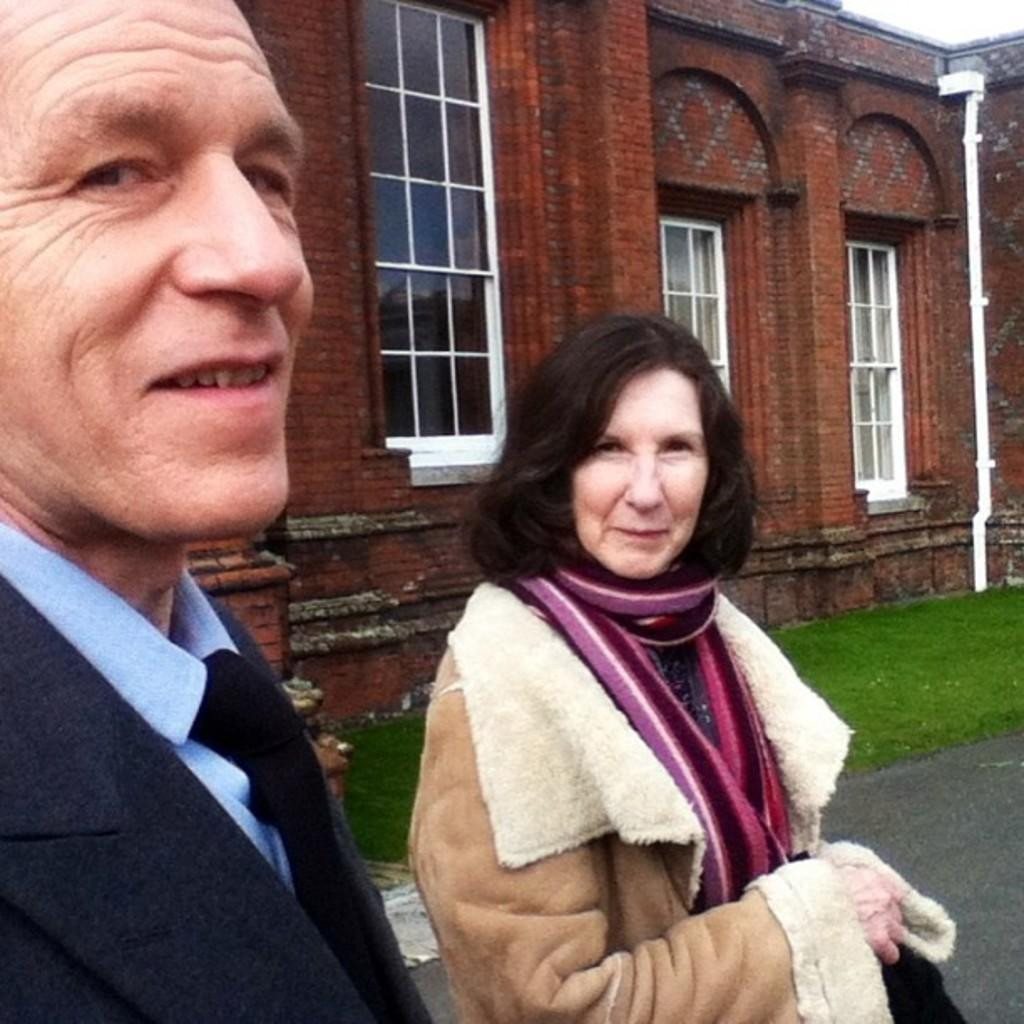How many people are in the image? There are two people in the image, a man and a woman. What are the people in the image doing? The man and the woman are standing and smiling. What can be seen in the background of the image? There is a road, grass, and a building visible in the image. What part of the building can be seen in the image? The windows of the building are visible. What type of arch can be seen in the image? There is no arch present in the image. How many quinces are visible in the image? There are no quinces present in the image. 